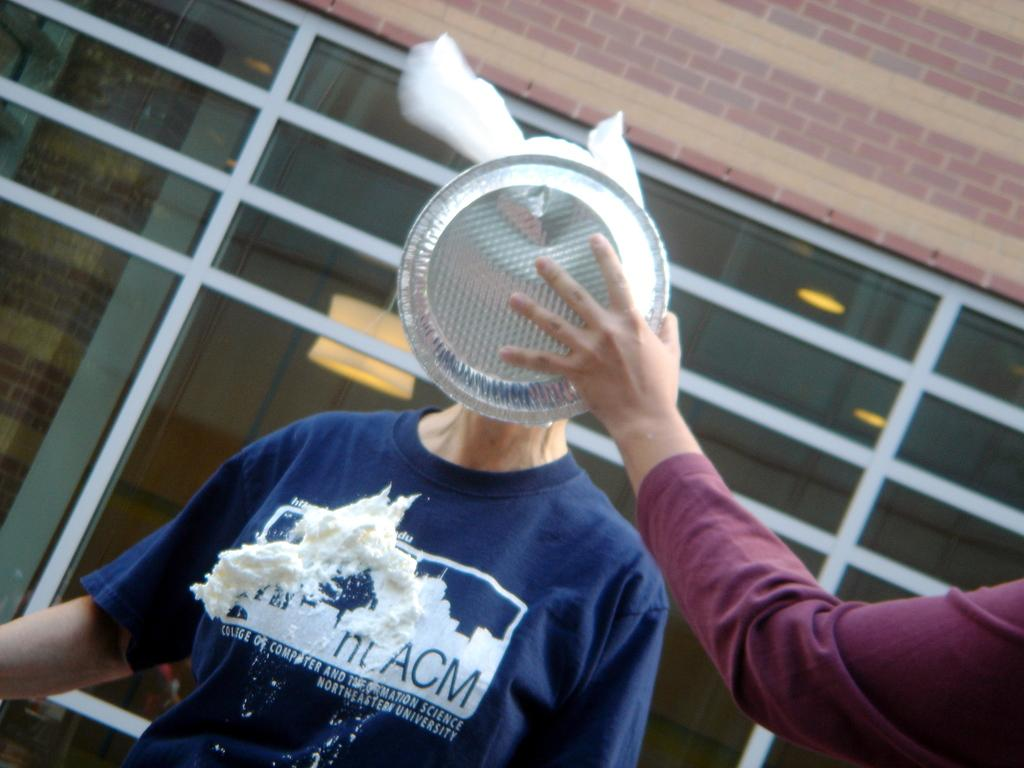Who or what is present in the image? There is a person in the image. What is the person holding in the image? The person's hand is holding a plate. What can be seen in the background of the image? There is a wall in the background of the image. What is the person's opinion on the rain in the image? There is no mention of rain in the image, so it is impossible to determine the person's opinion on it. 